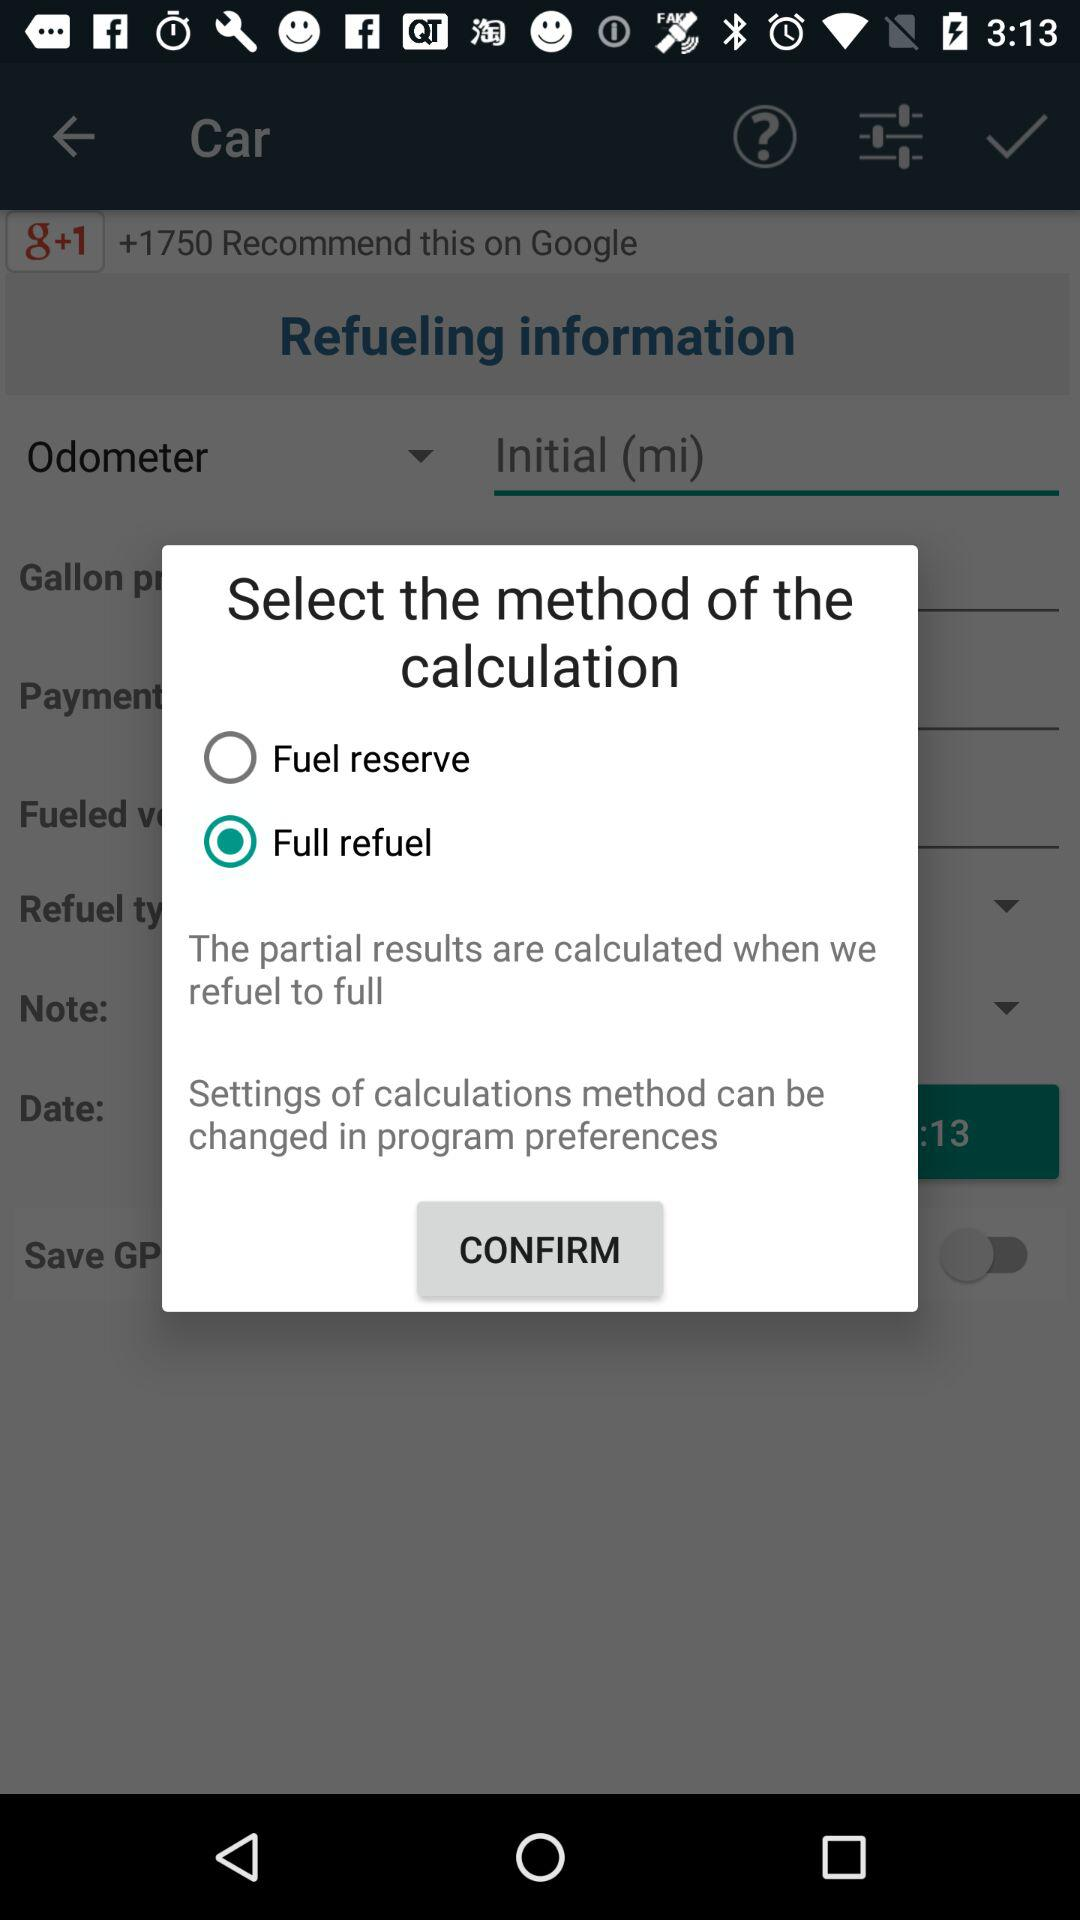Which method has been selected for calculation? The method "Full refuel" has been selected for calculation. 